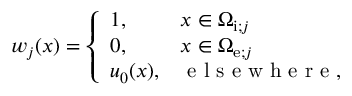<formula> <loc_0><loc_0><loc_500><loc_500>\begin{array} { r } { w _ { j } ( x ) = \left \{ \begin{array} { l l } { 1 , \quad } & { x \in \Omega _ { i ; j } } \\ { 0 , } & { x \in \Omega _ { e ; j } } \\ { u _ { 0 } ( x ) , } & { e l s e w h e r e , } \end{array} } \end{array}</formula> 